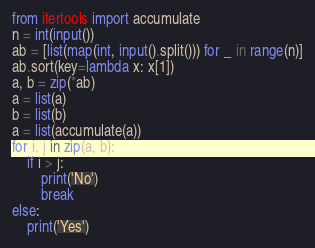<code> <loc_0><loc_0><loc_500><loc_500><_Python_>from itertools import accumulate
n = int(input())
ab = [list(map(int, input().split())) for _ in range(n)]
ab.sort(key=lambda x: x[1])
a, b = zip(*ab)
a = list(a)
b = list(b)
a = list(accumulate(a))
for i, j in zip(a, b):
    if i > j:
        print('No')
        break
else:
    print('Yes')</code> 